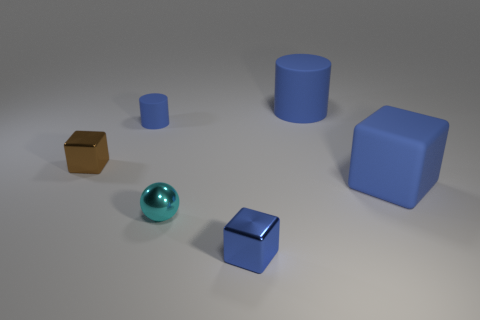Add 1 big blue matte objects. How many objects exist? 7 Subtract all balls. How many objects are left? 5 Add 1 tiny brown things. How many tiny brown things exist? 2 Subtract 0 cyan cylinders. How many objects are left? 6 Subtract all cylinders. Subtract all blue things. How many objects are left? 0 Add 6 blue shiny cubes. How many blue shiny cubes are left? 7 